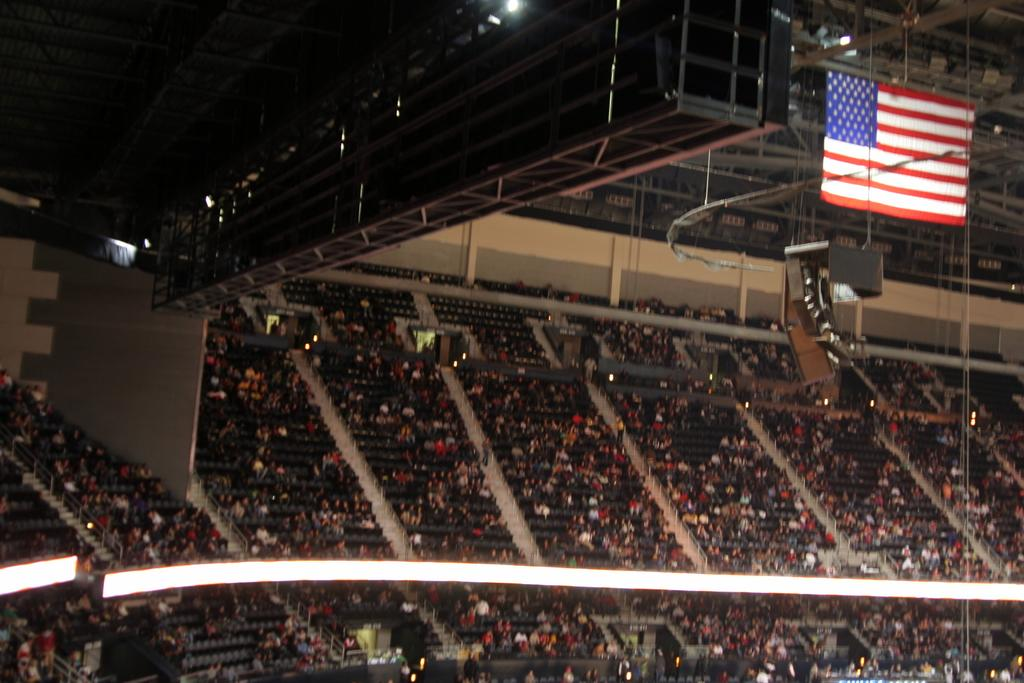What type of area is depicted in the image? There is a sitting area in the image. What are the people in the sitting area doing? People are sitting in the sitting area. Where is the sitting area located? The sitting area is part of a stadium. What can be seen at the top of the image? There is a flag and a roof visible at the top of the image. How many women are holding a paper in the image? There is no mention of women or paper in the image; it features a sitting area in a stadium with a flag and a roof. 